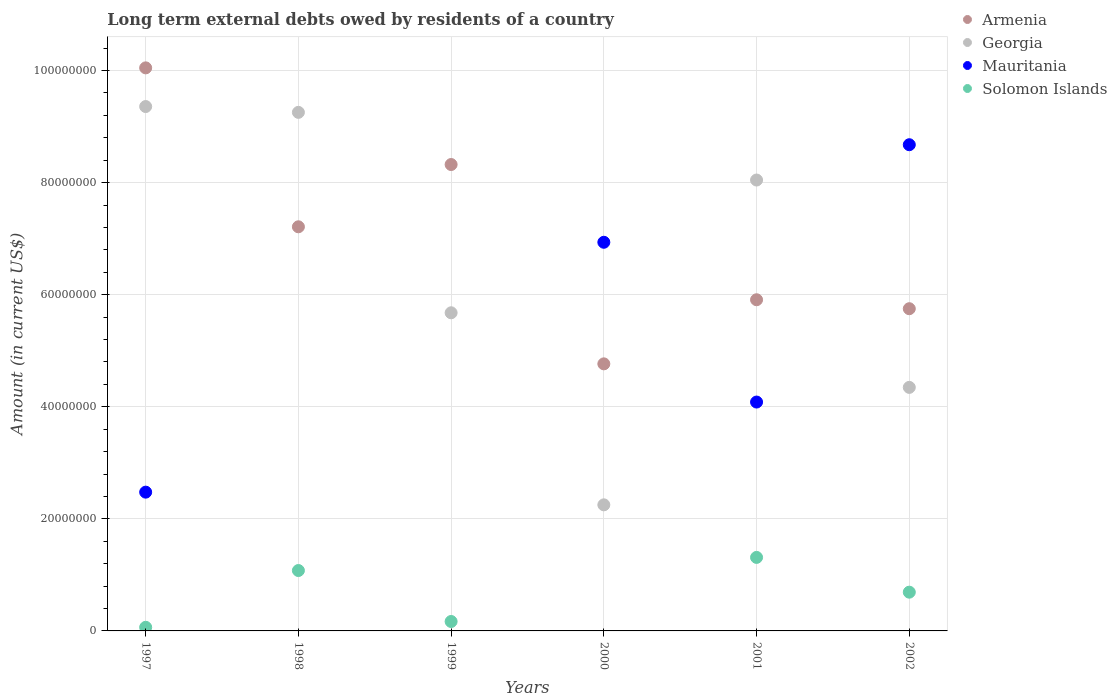How many different coloured dotlines are there?
Your answer should be very brief. 4. What is the amount of long-term external debts owed by residents in Armenia in 2002?
Provide a succinct answer. 5.75e+07. Across all years, what is the maximum amount of long-term external debts owed by residents in Mauritania?
Your answer should be very brief. 8.68e+07. Across all years, what is the minimum amount of long-term external debts owed by residents in Georgia?
Your response must be concise. 2.25e+07. In which year was the amount of long-term external debts owed by residents in Armenia maximum?
Ensure brevity in your answer.  1997. What is the total amount of long-term external debts owed by residents in Mauritania in the graph?
Offer a terse response. 2.22e+08. What is the difference between the amount of long-term external debts owed by residents in Solomon Islands in 1997 and that in 1998?
Make the answer very short. -1.01e+07. What is the difference between the amount of long-term external debts owed by residents in Georgia in 2002 and the amount of long-term external debts owed by residents in Solomon Islands in 1999?
Give a very brief answer. 4.18e+07. What is the average amount of long-term external debts owed by residents in Georgia per year?
Offer a terse response. 6.49e+07. In the year 1997, what is the difference between the amount of long-term external debts owed by residents in Armenia and amount of long-term external debts owed by residents in Mauritania?
Make the answer very short. 7.57e+07. In how many years, is the amount of long-term external debts owed by residents in Mauritania greater than 20000000 US$?
Offer a terse response. 4. What is the ratio of the amount of long-term external debts owed by residents in Mauritania in 1997 to that in 2000?
Provide a short and direct response. 0.36. Is the amount of long-term external debts owed by residents in Georgia in 1998 less than that in 1999?
Offer a terse response. No. Is the difference between the amount of long-term external debts owed by residents in Armenia in 1997 and 2002 greater than the difference between the amount of long-term external debts owed by residents in Mauritania in 1997 and 2002?
Make the answer very short. Yes. What is the difference between the highest and the second highest amount of long-term external debts owed by residents in Georgia?
Your answer should be compact. 1.04e+06. What is the difference between the highest and the lowest amount of long-term external debts owed by residents in Armenia?
Your answer should be compact. 5.28e+07. Is it the case that in every year, the sum of the amount of long-term external debts owed by residents in Mauritania and amount of long-term external debts owed by residents in Armenia  is greater than the sum of amount of long-term external debts owed by residents in Solomon Islands and amount of long-term external debts owed by residents in Georgia?
Ensure brevity in your answer.  No. Is it the case that in every year, the sum of the amount of long-term external debts owed by residents in Georgia and amount of long-term external debts owed by residents in Armenia  is greater than the amount of long-term external debts owed by residents in Mauritania?
Ensure brevity in your answer.  Yes. Is the amount of long-term external debts owed by residents in Mauritania strictly less than the amount of long-term external debts owed by residents in Solomon Islands over the years?
Ensure brevity in your answer.  No. What is the difference between two consecutive major ticks on the Y-axis?
Offer a very short reply. 2.00e+07. Are the values on the major ticks of Y-axis written in scientific E-notation?
Your answer should be very brief. No. Does the graph contain grids?
Your response must be concise. Yes. What is the title of the graph?
Your response must be concise. Long term external debts owed by residents of a country. What is the label or title of the X-axis?
Your response must be concise. Years. What is the label or title of the Y-axis?
Give a very brief answer. Amount (in current US$). What is the Amount (in current US$) of Armenia in 1997?
Offer a very short reply. 1.00e+08. What is the Amount (in current US$) in Georgia in 1997?
Offer a very short reply. 9.36e+07. What is the Amount (in current US$) in Mauritania in 1997?
Your response must be concise. 2.48e+07. What is the Amount (in current US$) of Solomon Islands in 1997?
Ensure brevity in your answer.  6.45e+05. What is the Amount (in current US$) in Armenia in 1998?
Give a very brief answer. 7.21e+07. What is the Amount (in current US$) in Georgia in 1998?
Provide a succinct answer. 9.25e+07. What is the Amount (in current US$) of Mauritania in 1998?
Provide a succinct answer. 0. What is the Amount (in current US$) in Solomon Islands in 1998?
Your answer should be very brief. 1.08e+07. What is the Amount (in current US$) of Armenia in 1999?
Make the answer very short. 8.32e+07. What is the Amount (in current US$) of Georgia in 1999?
Offer a very short reply. 5.68e+07. What is the Amount (in current US$) of Solomon Islands in 1999?
Offer a very short reply. 1.68e+06. What is the Amount (in current US$) in Armenia in 2000?
Ensure brevity in your answer.  4.77e+07. What is the Amount (in current US$) in Georgia in 2000?
Offer a terse response. 2.25e+07. What is the Amount (in current US$) in Mauritania in 2000?
Ensure brevity in your answer.  6.94e+07. What is the Amount (in current US$) in Armenia in 2001?
Your answer should be very brief. 5.91e+07. What is the Amount (in current US$) in Georgia in 2001?
Your response must be concise. 8.05e+07. What is the Amount (in current US$) in Mauritania in 2001?
Give a very brief answer. 4.08e+07. What is the Amount (in current US$) in Solomon Islands in 2001?
Your answer should be compact. 1.31e+07. What is the Amount (in current US$) in Armenia in 2002?
Your response must be concise. 5.75e+07. What is the Amount (in current US$) of Georgia in 2002?
Your answer should be very brief. 4.35e+07. What is the Amount (in current US$) of Mauritania in 2002?
Give a very brief answer. 8.68e+07. What is the Amount (in current US$) of Solomon Islands in 2002?
Offer a very short reply. 6.92e+06. Across all years, what is the maximum Amount (in current US$) of Armenia?
Your answer should be compact. 1.00e+08. Across all years, what is the maximum Amount (in current US$) in Georgia?
Provide a short and direct response. 9.36e+07. Across all years, what is the maximum Amount (in current US$) of Mauritania?
Your answer should be very brief. 8.68e+07. Across all years, what is the maximum Amount (in current US$) of Solomon Islands?
Your answer should be compact. 1.31e+07. Across all years, what is the minimum Amount (in current US$) in Armenia?
Offer a terse response. 4.77e+07. Across all years, what is the minimum Amount (in current US$) of Georgia?
Your response must be concise. 2.25e+07. Across all years, what is the minimum Amount (in current US$) in Mauritania?
Ensure brevity in your answer.  0. Across all years, what is the minimum Amount (in current US$) in Solomon Islands?
Offer a very short reply. 0. What is the total Amount (in current US$) of Armenia in the graph?
Your response must be concise. 4.20e+08. What is the total Amount (in current US$) in Georgia in the graph?
Offer a terse response. 3.89e+08. What is the total Amount (in current US$) of Mauritania in the graph?
Provide a succinct answer. 2.22e+08. What is the total Amount (in current US$) of Solomon Islands in the graph?
Keep it short and to the point. 3.31e+07. What is the difference between the Amount (in current US$) of Armenia in 1997 and that in 1998?
Offer a very short reply. 2.84e+07. What is the difference between the Amount (in current US$) of Georgia in 1997 and that in 1998?
Keep it short and to the point. 1.04e+06. What is the difference between the Amount (in current US$) in Solomon Islands in 1997 and that in 1998?
Give a very brief answer. -1.01e+07. What is the difference between the Amount (in current US$) in Armenia in 1997 and that in 1999?
Your response must be concise. 1.72e+07. What is the difference between the Amount (in current US$) of Georgia in 1997 and that in 1999?
Offer a very short reply. 3.68e+07. What is the difference between the Amount (in current US$) of Solomon Islands in 1997 and that in 1999?
Ensure brevity in your answer.  -1.04e+06. What is the difference between the Amount (in current US$) of Armenia in 1997 and that in 2000?
Your response must be concise. 5.28e+07. What is the difference between the Amount (in current US$) of Georgia in 1997 and that in 2000?
Provide a short and direct response. 7.11e+07. What is the difference between the Amount (in current US$) in Mauritania in 1997 and that in 2000?
Your answer should be compact. -4.46e+07. What is the difference between the Amount (in current US$) in Armenia in 1997 and that in 2001?
Your response must be concise. 4.14e+07. What is the difference between the Amount (in current US$) in Georgia in 1997 and that in 2001?
Your answer should be compact. 1.31e+07. What is the difference between the Amount (in current US$) of Mauritania in 1997 and that in 2001?
Provide a short and direct response. -1.61e+07. What is the difference between the Amount (in current US$) of Solomon Islands in 1997 and that in 2001?
Ensure brevity in your answer.  -1.25e+07. What is the difference between the Amount (in current US$) in Armenia in 1997 and that in 2002?
Your response must be concise. 4.30e+07. What is the difference between the Amount (in current US$) of Georgia in 1997 and that in 2002?
Ensure brevity in your answer.  5.01e+07. What is the difference between the Amount (in current US$) in Mauritania in 1997 and that in 2002?
Offer a very short reply. -6.20e+07. What is the difference between the Amount (in current US$) of Solomon Islands in 1997 and that in 2002?
Give a very brief answer. -6.27e+06. What is the difference between the Amount (in current US$) in Armenia in 1998 and that in 1999?
Give a very brief answer. -1.11e+07. What is the difference between the Amount (in current US$) of Georgia in 1998 and that in 1999?
Provide a succinct answer. 3.58e+07. What is the difference between the Amount (in current US$) in Solomon Islands in 1998 and that in 1999?
Your answer should be very brief. 9.10e+06. What is the difference between the Amount (in current US$) of Armenia in 1998 and that in 2000?
Ensure brevity in your answer.  2.45e+07. What is the difference between the Amount (in current US$) in Georgia in 1998 and that in 2000?
Provide a short and direct response. 7.00e+07. What is the difference between the Amount (in current US$) in Armenia in 1998 and that in 2001?
Give a very brief answer. 1.30e+07. What is the difference between the Amount (in current US$) in Georgia in 1998 and that in 2001?
Provide a short and direct response. 1.21e+07. What is the difference between the Amount (in current US$) in Solomon Islands in 1998 and that in 2001?
Your response must be concise. -2.34e+06. What is the difference between the Amount (in current US$) in Armenia in 1998 and that in 2002?
Offer a terse response. 1.46e+07. What is the difference between the Amount (in current US$) in Georgia in 1998 and that in 2002?
Your answer should be very brief. 4.91e+07. What is the difference between the Amount (in current US$) in Solomon Islands in 1998 and that in 2002?
Make the answer very short. 3.86e+06. What is the difference between the Amount (in current US$) of Armenia in 1999 and that in 2000?
Offer a very short reply. 3.56e+07. What is the difference between the Amount (in current US$) in Georgia in 1999 and that in 2000?
Give a very brief answer. 3.43e+07. What is the difference between the Amount (in current US$) in Armenia in 1999 and that in 2001?
Give a very brief answer. 2.41e+07. What is the difference between the Amount (in current US$) of Georgia in 1999 and that in 2001?
Make the answer very short. -2.37e+07. What is the difference between the Amount (in current US$) in Solomon Islands in 1999 and that in 2001?
Provide a succinct answer. -1.14e+07. What is the difference between the Amount (in current US$) of Armenia in 1999 and that in 2002?
Provide a succinct answer. 2.57e+07. What is the difference between the Amount (in current US$) in Georgia in 1999 and that in 2002?
Provide a short and direct response. 1.33e+07. What is the difference between the Amount (in current US$) in Solomon Islands in 1999 and that in 2002?
Your answer should be compact. -5.23e+06. What is the difference between the Amount (in current US$) in Armenia in 2000 and that in 2001?
Provide a succinct answer. -1.14e+07. What is the difference between the Amount (in current US$) of Georgia in 2000 and that in 2001?
Make the answer very short. -5.80e+07. What is the difference between the Amount (in current US$) in Mauritania in 2000 and that in 2001?
Provide a succinct answer. 2.85e+07. What is the difference between the Amount (in current US$) in Armenia in 2000 and that in 2002?
Provide a succinct answer. -9.84e+06. What is the difference between the Amount (in current US$) in Georgia in 2000 and that in 2002?
Keep it short and to the point. -2.10e+07. What is the difference between the Amount (in current US$) of Mauritania in 2000 and that in 2002?
Provide a succinct answer. -1.74e+07. What is the difference between the Amount (in current US$) of Armenia in 2001 and that in 2002?
Make the answer very short. 1.60e+06. What is the difference between the Amount (in current US$) of Georgia in 2001 and that in 2002?
Offer a terse response. 3.70e+07. What is the difference between the Amount (in current US$) of Mauritania in 2001 and that in 2002?
Give a very brief answer. -4.59e+07. What is the difference between the Amount (in current US$) of Solomon Islands in 2001 and that in 2002?
Offer a very short reply. 6.20e+06. What is the difference between the Amount (in current US$) in Armenia in 1997 and the Amount (in current US$) in Georgia in 1998?
Your response must be concise. 7.94e+06. What is the difference between the Amount (in current US$) of Armenia in 1997 and the Amount (in current US$) of Solomon Islands in 1998?
Provide a short and direct response. 8.97e+07. What is the difference between the Amount (in current US$) in Georgia in 1997 and the Amount (in current US$) in Solomon Islands in 1998?
Provide a short and direct response. 8.28e+07. What is the difference between the Amount (in current US$) in Mauritania in 1997 and the Amount (in current US$) in Solomon Islands in 1998?
Offer a very short reply. 1.40e+07. What is the difference between the Amount (in current US$) of Armenia in 1997 and the Amount (in current US$) of Georgia in 1999?
Give a very brief answer. 4.37e+07. What is the difference between the Amount (in current US$) in Armenia in 1997 and the Amount (in current US$) in Solomon Islands in 1999?
Provide a short and direct response. 9.88e+07. What is the difference between the Amount (in current US$) of Georgia in 1997 and the Amount (in current US$) of Solomon Islands in 1999?
Provide a succinct answer. 9.19e+07. What is the difference between the Amount (in current US$) of Mauritania in 1997 and the Amount (in current US$) of Solomon Islands in 1999?
Provide a short and direct response. 2.31e+07. What is the difference between the Amount (in current US$) of Armenia in 1997 and the Amount (in current US$) of Georgia in 2000?
Keep it short and to the point. 7.80e+07. What is the difference between the Amount (in current US$) of Armenia in 1997 and the Amount (in current US$) of Mauritania in 2000?
Make the answer very short. 3.11e+07. What is the difference between the Amount (in current US$) of Georgia in 1997 and the Amount (in current US$) of Mauritania in 2000?
Your response must be concise. 2.42e+07. What is the difference between the Amount (in current US$) of Armenia in 1997 and the Amount (in current US$) of Georgia in 2001?
Give a very brief answer. 2.00e+07. What is the difference between the Amount (in current US$) of Armenia in 1997 and the Amount (in current US$) of Mauritania in 2001?
Your answer should be very brief. 5.96e+07. What is the difference between the Amount (in current US$) of Armenia in 1997 and the Amount (in current US$) of Solomon Islands in 2001?
Provide a short and direct response. 8.74e+07. What is the difference between the Amount (in current US$) in Georgia in 1997 and the Amount (in current US$) in Mauritania in 2001?
Your response must be concise. 5.27e+07. What is the difference between the Amount (in current US$) in Georgia in 1997 and the Amount (in current US$) in Solomon Islands in 2001?
Keep it short and to the point. 8.05e+07. What is the difference between the Amount (in current US$) in Mauritania in 1997 and the Amount (in current US$) in Solomon Islands in 2001?
Provide a short and direct response. 1.16e+07. What is the difference between the Amount (in current US$) in Armenia in 1997 and the Amount (in current US$) in Georgia in 2002?
Ensure brevity in your answer.  5.70e+07. What is the difference between the Amount (in current US$) of Armenia in 1997 and the Amount (in current US$) of Mauritania in 2002?
Give a very brief answer. 1.37e+07. What is the difference between the Amount (in current US$) of Armenia in 1997 and the Amount (in current US$) of Solomon Islands in 2002?
Give a very brief answer. 9.36e+07. What is the difference between the Amount (in current US$) in Georgia in 1997 and the Amount (in current US$) in Mauritania in 2002?
Your answer should be compact. 6.81e+06. What is the difference between the Amount (in current US$) of Georgia in 1997 and the Amount (in current US$) of Solomon Islands in 2002?
Make the answer very short. 8.67e+07. What is the difference between the Amount (in current US$) in Mauritania in 1997 and the Amount (in current US$) in Solomon Islands in 2002?
Your answer should be compact. 1.78e+07. What is the difference between the Amount (in current US$) of Armenia in 1998 and the Amount (in current US$) of Georgia in 1999?
Offer a terse response. 1.53e+07. What is the difference between the Amount (in current US$) of Armenia in 1998 and the Amount (in current US$) of Solomon Islands in 1999?
Your response must be concise. 7.04e+07. What is the difference between the Amount (in current US$) of Georgia in 1998 and the Amount (in current US$) of Solomon Islands in 1999?
Provide a short and direct response. 9.09e+07. What is the difference between the Amount (in current US$) of Armenia in 1998 and the Amount (in current US$) of Georgia in 2000?
Offer a very short reply. 4.96e+07. What is the difference between the Amount (in current US$) of Armenia in 1998 and the Amount (in current US$) of Mauritania in 2000?
Offer a very short reply. 2.76e+06. What is the difference between the Amount (in current US$) of Georgia in 1998 and the Amount (in current US$) of Mauritania in 2000?
Your answer should be very brief. 2.32e+07. What is the difference between the Amount (in current US$) of Armenia in 1998 and the Amount (in current US$) of Georgia in 2001?
Offer a very short reply. -8.34e+06. What is the difference between the Amount (in current US$) of Armenia in 1998 and the Amount (in current US$) of Mauritania in 2001?
Give a very brief answer. 3.13e+07. What is the difference between the Amount (in current US$) of Armenia in 1998 and the Amount (in current US$) of Solomon Islands in 2001?
Provide a short and direct response. 5.90e+07. What is the difference between the Amount (in current US$) in Georgia in 1998 and the Amount (in current US$) in Mauritania in 2001?
Make the answer very short. 5.17e+07. What is the difference between the Amount (in current US$) of Georgia in 1998 and the Amount (in current US$) of Solomon Islands in 2001?
Keep it short and to the point. 7.94e+07. What is the difference between the Amount (in current US$) in Armenia in 1998 and the Amount (in current US$) in Georgia in 2002?
Ensure brevity in your answer.  2.87e+07. What is the difference between the Amount (in current US$) of Armenia in 1998 and the Amount (in current US$) of Mauritania in 2002?
Offer a very short reply. -1.46e+07. What is the difference between the Amount (in current US$) in Armenia in 1998 and the Amount (in current US$) in Solomon Islands in 2002?
Your answer should be compact. 6.52e+07. What is the difference between the Amount (in current US$) of Georgia in 1998 and the Amount (in current US$) of Mauritania in 2002?
Provide a short and direct response. 5.77e+06. What is the difference between the Amount (in current US$) in Georgia in 1998 and the Amount (in current US$) in Solomon Islands in 2002?
Ensure brevity in your answer.  8.56e+07. What is the difference between the Amount (in current US$) of Armenia in 1999 and the Amount (in current US$) of Georgia in 2000?
Make the answer very short. 6.07e+07. What is the difference between the Amount (in current US$) of Armenia in 1999 and the Amount (in current US$) of Mauritania in 2000?
Provide a short and direct response. 1.39e+07. What is the difference between the Amount (in current US$) of Georgia in 1999 and the Amount (in current US$) of Mauritania in 2000?
Provide a short and direct response. -1.26e+07. What is the difference between the Amount (in current US$) in Armenia in 1999 and the Amount (in current US$) in Georgia in 2001?
Your response must be concise. 2.77e+06. What is the difference between the Amount (in current US$) of Armenia in 1999 and the Amount (in current US$) of Mauritania in 2001?
Offer a terse response. 4.24e+07. What is the difference between the Amount (in current US$) in Armenia in 1999 and the Amount (in current US$) in Solomon Islands in 2001?
Your response must be concise. 7.01e+07. What is the difference between the Amount (in current US$) of Georgia in 1999 and the Amount (in current US$) of Mauritania in 2001?
Provide a succinct answer. 1.59e+07. What is the difference between the Amount (in current US$) of Georgia in 1999 and the Amount (in current US$) of Solomon Islands in 2001?
Your answer should be very brief. 4.37e+07. What is the difference between the Amount (in current US$) in Armenia in 1999 and the Amount (in current US$) in Georgia in 2002?
Ensure brevity in your answer.  3.98e+07. What is the difference between the Amount (in current US$) in Armenia in 1999 and the Amount (in current US$) in Mauritania in 2002?
Your response must be concise. -3.54e+06. What is the difference between the Amount (in current US$) of Armenia in 1999 and the Amount (in current US$) of Solomon Islands in 2002?
Ensure brevity in your answer.  7.63e+07. What is the difference between the Amount (in current US$) in Georgia in 1999 and the Amount (in current US$) in Mauritania in 2002?
Give a very brief answer. -3.00e+07. What is the difference between the Amount (in current US$) of Georgia in 1999 and the Amount (in current US$) of Solomon Islands in 2002?
Make the answer very short. 4.99e+07. What is the difference between the Amount (in current US$) in Armenia in 2000 and the Amount (in current US$) in Georgia in 2001?
Offer a very short reply. -3.28e+07. What is the difference between the Amount (in current US$) in Armenia in 2000 and the Amount (in current US$) in Mauritania in 2001?
Ensure brevity in your answer.  6.82e+06. What is the difference between the Amount (in current US$) in Armenia in 2000 and the Amount (in current US$) in Solomon Islands in 2001?
Make the answer very short. 3.45e+07. What is the difference between the Amount (in current US$) in Georgia in 2000 and the Amount (in current US$) in Mauritania in 2001?
Provide a succinct answer. -1.83e+07. What is the difference between the Amount (in current US$) in Georgia in 2000 and the Amount (in current US$) in Solomon Islands in 2001?
Ensure brevity in your answer.  9.38e+06. What is the difference between the Amount (in current US$) of Mauritania in 2000 and the Amount (in current US$) of Solomon Islands in 2001?
Provide a short and direct response. 5.62e+07. What is the difference between the Amount (in current US$) of Armenia in 2000 and the Amount (in current US$) of Georgia in 2002?
Offer a terse response. 4.20e+06. What is the difference between the Amount (in current US$) in Armenia in 2000 and the Amount (in current US$) in Mauritania in 2002?
Provide a short and direct response. -3.91e+07. What is the difference between the Amount (in current US$) of Armenia in 2000 and the Amount (in current US$) of Solomon Islands in 2002?
Provide a succinct answer. 4.07e+07. What is the difference between the Amount (in current US$) of Georgia in 2000 and the Amount (in current US$) of Mauritania in 2002?
Make the answer very short. -6.43e+07. What is the difference between the Amount (in current US$) in Georgia in 2000 and the Amount (in current US$) in Solomon Islands in 2002?
Your answer should be compact. 1.56e+07. What is the difference between the Amount (in current US$) of Mauritania in 2000 and the Amount (in current US$) of Solomon Islands in 2002?
Your answer should be compact. 6.24e+07. What is the difference between the Amount (in current US$) in Armenia in 2001 and the Amount (in current US$) in Georgia in 2002?
Offer a terse response. 1.56e+07. What is the difference between the Amount (in current US$) in Armenia in 2001 and the Amount (in current US$) in Mauritania in 2002?
Your answer should be compact. -2.77e+07. What is the difference between the Amount (in current US$) of Armenia in 2001 and the Amount (in current US$) of Solomon Islands in 2002?
Keep it short and to the point. 5.22e+07. What is the difference between the Amount (in current US$) of Georgia in 2001 and the Amount (in current US$) of Mauritania in 2002?
Your answer should be very brief. -6.30e+06. What is the difference between the Amount (in current US$) in Georgia in 2001 and the Amount (in current US$) in Solomon Islands in 2002?
Make the answer very short. 7.35e+07. What is the difference between the Amount (in current US$) in Mauritania in 2001 and the Amount (in current US$) in Solomon Islands in 2002?
Give a very brief answer. 3.39e+07. What is the average Amount (in current US$) in Armenia per year?
Provide a succinct answer. 7.00e+07. What is the average Amount (in current US$) of Georgia per year?
Offer a terse response. 6.49e+07. What is the average Amount (in current US$) in Mauritania per year?
Your answer should be compact. 3.70e+07. What is the average Amount (in current US$) of Solomon Islands per year?
Keep it short and to the point. 5.52e+06. In the year 1997, what is the difference between the Amount (in current US$) in Armenia and Amount (in current US$) in Georgia?
Provide a succinct answer. 6.90e+06. In the year 1997, what is the difference between the Amount (in current US$) of Armenia and Amount (in current US$) of Mauritania?
Make the answer very short. 7.57e+07. In the year 1997, what is the difference between the Amount (in current US$) in Armenia and Amount (in current US$) in Solomon Islands?
Your response must be concise. 9.98e+07. In the year 1997, what is the difference between the Amount (in current US$) of Georgia and Amount (in current US$) of Mauritania?
Give a very brief answer. 6.88e+07. In the year 1997, what is the difference between the Amount (in current US$) of Georgia and Amount (in current US$) of Solomon Islands?
Ensure brevity in your answer.  9.29e+07. In the year 1997, what is the difference between the Amount (in current US$) of Mauritania and Amount (in current US$) of Solomon Islands?
Provide a succinct answer. 2.41e+07. In the year 1998, what is the difference between the Amount (in current US$) in Armenia and Amount (in current US$) in Georgia?
Ensure brevity in your answer.  -2.04e+07. In the year 1998, what is the difference between the Amount (in current US$) in Armenia and Amount (in current US$) in Solomon Islands?
Your response must be concise. 6.13e+07. In the year 1998, what is the difference between the Amount (in current US$) of Georgia and Amount (in current US$) of Solomon Islands?
Give a very brief answer. 8.18e+07. In the year 1999, what is the difference between the Amount (in current US$) of Armenia and Amount (in current US$) of Georgia?
Offer a terse response. 2.65e+07. In the year 1999, what is the difference between the Amount (in current US$) in Armenia and Amount (in current US$) in Solomon Islands?
Make the answer very short. 8.15e+07. In the year 1999, what is the difference between the Amount (in current US$) in Georgia and Amount (in current US$) in Solomon Islands?
Provide a succinct answer. 5.51e+07. In the year 2000, what is the difference between the Amount (in current US$) in Armenia and Amount (in current US$) in Georgia?
Your response must be concise. 2.52e+07. In the year 2000, what is the difference between the Amount (in current US$) of Armenia and Amount (in current US$) of Mauritania?
Provide a short and direct response. -2.17e+07. In the year 2000, what is the difference between the Amount (in current US$) of Georgia and Amount (in current US$) of Mauritania?
Your answer should be very brief. -4.69e+07. In the year 2001, what is the difference between the Amount (in current US$) in Armenia and Amount (in current US$) in Georgia?
Ensure brevity in your answer.  -2.14e+07. In the year 2001, what is the difference between the Amount (in current US$) in Armenia and Amount (in current US$) in Mauritania?
Your response must be concise. 1.83e+07. In the year 2001, what is the difference between the Amount (in current US$) of Armenia and Amount (in current US$) of Solomon Islands?
Provide a succinct answer. 4.60e+07. In the year 2001, what is the difference between the Amount (in current US$) in Georgia and Amount (in current US$) in Mauritania?
Ensure brevity in your answer.  3.96e+07. In the year 2001, what is the difference between the Amount (in current US$) of Georgia and Amount (in current US$) of Solomon Islands?
Give a very brief answer. 6.73e+07. In the year 2001, what is the difference between the Amount (in current US$) of Mauritania and Amount (in current US$) of Solomon Islands?
Your response must be concise. 2.77e+07. In the year 2002, what is the difference between the Amount (in current US$) of Armenia and Amount (in current US$) of Georgia?
Provide a succinct answer. 1.40e+07. In the year 2002, what is the difference between the Amount (in current US$) in Armenia and Amount (in current US$) in Mauritania?
Your response must be concise. -2.93e+07. In the year 2002, what is the difference between the Amount (in current US$) of Armenia and Amount (in current US$) of Solomon Islands?
Ensure brevity in your answer.  5.06e+07. In the year 2002, what is the difference between the Amount (in current US$) of Georgia and Amount (in current US$) of Mauritania?
Your answer should be very brief. -4.33e+07. In the year 2002, what is the difference between the Amount (in current US$) of Georgia and Amount (in current US$) of Solomon Islands?
Make the answer very short. 3.65e+07. In the year 2002, what is the difference between the Amount (in current US$) of Mauritania and Amount (in current US$) of Solomon Islands?
Your answer should be compact. 7.98e+07. What is the ratio of the Amount (in current US$) of Armenia in 1997 to that in 1998?
Your answer should be compact. 1.39. What is the ratio of the Amount (in current US$) of Georgia in 1997 to that in 1998?
Your answer should be very brief. 1.01. What is the ratio of the Amount (in current US$) in Solomon Islands in 1997 to that in 1998?
Your response must be concise. 0.06. What is the ratio of the Amount (in current US$) in Armenia in 1997 to that in 1999?
Ensure brevity in your answer.  1.21. What is the ratio of the Amount (in current US$) in Georgia in 1997 to that in 1999?
Your response must be concise. 1.65. What is the ratio of the Amount (in current US$) of Solomon Islands in 1997 to that in 1999?
Your response must be concise. 0.38. What is the ratio of the Amount (in current US$) of Armenia in 1997 to that in 2000?
Keep it short and to the point. 2.11. What is the ratio of the Amount (in current US$) of Georgia in 1997 to that in 2000?
Your answer should be compact. 4.16. What is the ratio of the Amount (in current US$) in Mauritania in 1997 to that in 2000?
Make the answer very short. 0.36. What is the ratio of the Amount (in current US$) of Armenia in 1997 to that in 2001?
Make the answer very short. 1.7. What is the ratio of the Amount (in current US$) of Georgia in 1997 to that in 2001?
Offer a terse response. 1.16. What is the ratio of the Amount (in current US$) in Mauritania in 1997 to that in 2001?
Make the answer very short. 0.61. What is the ratio of the Amount (in current US$) of Solomon Islands in 1997 to that in 2001?
Offer a very short reply. 0.05. What is the ratio of the Amount (in current US$) in Armenia in 1997 to that in 2002?
Your answer should be compact. 1.75. What is the ratio of the Amount (in current US$) in Georgia in 1997 to that in 2002?
Provide a succinct answer. 2.15. What is the ratio of the Amount (in current US$) of Mauritania in 1997 to that in 2002?
Your response must be concise. 0.29. What is the ratio of the Amount (in current US$) in Solomon Islands in 1997 to that in 2002?
Keep it short and to the point. 0.09. What is the ratio of the Amount (in current US$) in Armenia in 1998 to that in 1999?
Your answer should be very brief. 0.87. What is the ratio of the Amount (in current US$) of Georgia in 1998 to that in 1999?
Offer a very short reply. 1.63. What is the ratio of the Amount (in current US$) of Solomon Islands in 1998 to that in 1999?
Offer a very short reply. 6.41. What is the ratio of the Amount (in current US$) of Armenia in 1998 to that in 2000?
Make the answer very short. 1.51. What is the ratio of the Amount (in current US$) in Georgia in 1998 to that in 2000?
Ensure brevity in your answer.  4.11. What is the ratio of the Amount (in current US$) of Armenia in 1998 to that in 2001?
Make the answer very short. 1.22. What is the ratio of the Amount (in current US$) in Georgia in 1998 to that in 2001?
Provide a succinct answer. 1.15. What is the ratio of the Amount (in current US$) in Solomon Islands in 1998 to that in 2001?
Offer a very short reply. 0.82. What is the ratio of the Amount (in current US$) in Armenia in 1998 to that in 2002?
Provide a succinct answer. 1.25. What is the ratio of the Amount (in current US$) in Georgia in 1998 to that in 2002?
Provide a short and direct response. 2.13. What is the ratio of the Amount (in current US$) in Solomon Islands in 1998 to that in 2002?
Give a very brief answer. 1.56. What is the ratio of the Amount (in current US$) in Armenia in 1999 to that in 2000?
Your answer should be very brief. 1.75. What is the ratio of the Amount (in current US$) in Georgia in 1999 to that in 2000?
Provide a short and direct response. 2.52. What is the ratio of the Amount (in current US$) of Armenia in 1999 to that in 2001?
Keep it short and to the point. 1.41. What is the ratio of the Amount (in current US$) in Georgia in 1999 to that in 2001?
Give a very brief answer. 0.71. What is the ratio of the Amount (in current US$) of Solomon Islands in 1999 to that in 2001?
Provide a succinct answer. 0.13. What is the ratio of the Amount (in current US$) of Armenia in 1999 to that in 2002?
Provide a succinct answer. 1.45. What is the ratio of the Amount (in current US$) in Georgia in 1999 to that in 2002?
Offer a very short reply. 1.31. What is the ratio of the Amount (in current US$) in Solomon Islands in 1999 to that in 2002?
Give a very brief answer. 0.24. What is the ratio of the Amount (in current US$) in Armenia in 2000 to that in 2001?
Give a very brief answer. 0.81. What is the ratio of the Amount (in current US$) in Georgia in 2000 to that in 2001?
Your answer should be very brief. 0.28. What is the ratio of the Amount (in current US$) in Mauritania in 2000 to that in 2001?
Your response must be concise. 1.7. What is the ratio of the Amount (in current US$) of Armenia in 2000 to that in 2002?
Your answer should be compact. 0.83. What is the ratio of the Amount (in current US$) of Georgia in 2000 to that in 2002?
Your response must be concise. 0.52. What is the ratio of the Amount (in current US$) in Mauritania in 2000 to that in 2002?
Give a very brief answer. 0.8. What is the ratio of the Amount (in current US$) of Armenia in 2001 to that in 2002?
Offer a very short reply. 1.03. What is the ratio of the Amount (in current US$) of Georgia in 2001 to that in 2002?
Offer a very short reply. 1.85. What is the ratio of the Amount (in current US$) of Mauritania in 2001 to that in 2002?
Your answer should be compact. 0.47. What is the ratio of the Amount (in current US$) in Solomon Islands in 2001 to that in 2002?
Your answer should be very brief. 1.9. What is the difference between the highest and the second highest Amount (in current US$) in Armenia?
Provide a succinct answer. 1.72e+07. What is the difference between the highest and the second highest Amount (in current US$) of Georgia?
Offer a terse response. 1.04e+06. What is the difference between the highest and the second highest Amount (in current US$) of Mauritania?
Offer a terse response. 1.74e+07. What is the difference between the highest and the second highest Amount (in current US$) of Solomon Islands?
Give a very brief answer. 2.34e+06. What is the difference between the highest and the lowest Amount (in current US$) of Armenia?
Your answer should be very brief. 5.28e+07. What is the difference between the highest and the lowest Amount (in current US$) in Georgia?
Offer a very short reply. 7.11e+07. What is the difference between the highest and the lowest Amount (in current US$) in Mauritania?
Make the answer very short. 8.68e+07. What is the difference between the highest and the lowest Amount (in current US$) of Solomon Islands?
Ensure brevity in your answer.  1.31e+07. 